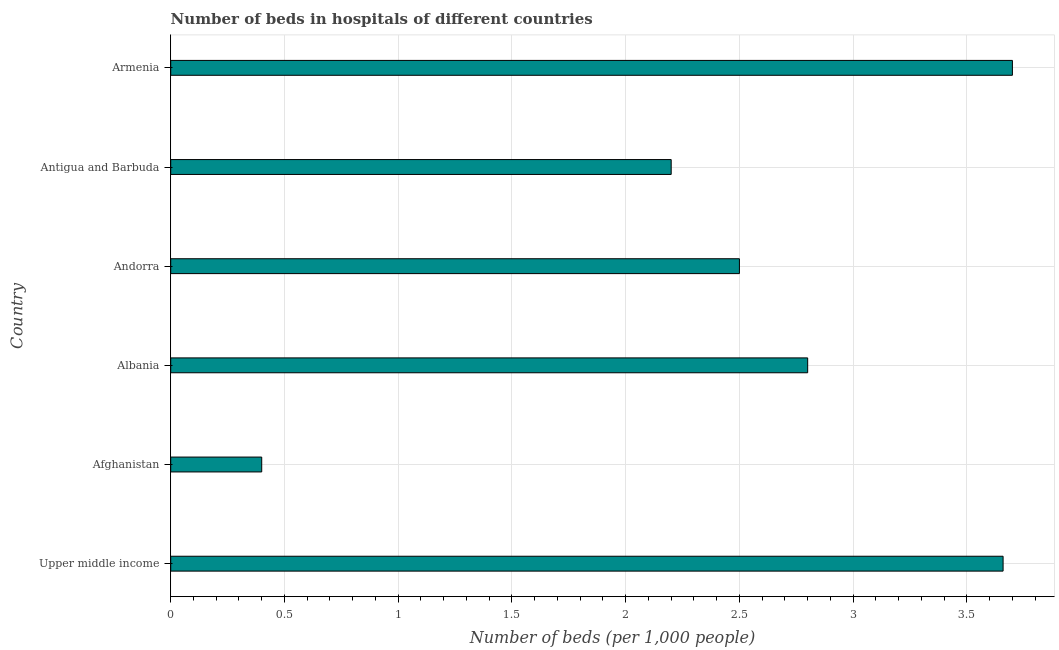Does the graph contain grids?
Provide a succinct answer. Yes. What is the title of the graph?
Offer a terse response. Number of beds in hospitals of different countries. What is the label or title of the X-axis?
Your response must be concise. Number of beds (per 1,0 people). Across all countries, what is the minimum number of hospital beds?
Give a very brief answer. 0.4. In which country was the number of hospital beds maximum?
Your response must be concise. Armenia. In which country was the number of hospital beds minimum?
Offer a very short reply. Afghanistan. What is the sum of the number of hospital beds?
Ensure brevity in your answer.  15.26. What is the average number of hospital beds per country?
Give a very brief answer. 2.54. What is the median number of hospital beds?
Your answer should be compact. 2.65. What is the ratio of the number of hospital beds in Afghanistan to that in Albania?
Provide a succinct answer. 0.14. What is the difference between the highest and the second highest number of hospital beds?
Your response must be concise. 0.04. In how many countries, is the number of hospital beds greater than the average number of hospital beds taken over all countries?
Provide a succinct answer. 3. What is the Number of beds (per 1,000 people) in Upper middle income?
Keep it short and to the point. 3.66. What is the Number of beds (per 1,000 people) in Afghanistan?
Give a very brief answer. 0.4. What is the Number of beds (per 1,000 people) of Andorra?
Provide a short and direct response. 2.5. What is the Number of beds (per 1,000 people) in Antigua and Barbuda?
Provide a succinct answer. 2.2. What is the difference between the Number of beds (per 1,000 people) in Upper middle income and Afghanistan?
Ensure brevity in your answer.  3.26. What is the difference between the Number of beds (per 1,000 people) in Upper middle income and Albania?
Offer a terse response. 0.86. What is the difference between the Number of beds (per 1,000 people) in Upper middle income and Andorra?
Offer a terse response. 1.16. What is the difference between the Number of beds (per 1,000 people) in Upper middle income and Antigua and Barbuda?
Ensure brevity in your answer.  1.46. What is the difference between the Number of beds (per 1,000 people) in Upper middle income and Armenia?
Keep it short and to the point. -0.04. What is the difference between the Number of beds (per 1,000 people) in Afghanistan and Albania?
Your answer should be very brief. -2.4. What is the difference between the Number of beds (per 1,000 people) in Afghanistan and Antigua and Barbuda?
Your answer should be compact. -1.8. What is the difference between the Number of beds (per 1,000 people) in Afghanistan and Armenia?
Your answer should be compact. -3.3. What is the difference between the Number of beds (per 1,000 people) in Albania and Andorra?
Ensure brevity in your answer.  0.3. What is the difference between the Number of beds (per 1,000 people) in Albania and Antigua and Barbuda?
Offer a terse response. 0.6. What is the difference between the Number of beds (per 1,000 people) in Albania and Armenia?
Your answer should be very brief. -0.9. What is the difference between the Number of beds (per 1,000 people) in Andorra and Antigua and Barbuda?
Your response must be concise. 0.3. What is the difference between the Number of beds (per 1,000 people) in Andorra and Armenia?
Your answer should be very brief. -1.2. What is the difference between the Number of beds (per 1,000 people) in Antigua and Barbuda and Armenia?
Ensure brevity in your answer.  -1.5. What is the ratio of the Number of beds (per 1,000 people) in Upper middle income to that in Afghanistan?
Ensure brevity in your answer.  9.15. What is the ratio of the Number of beds (per 1,000 people) in Upper middle income to that in Albania?
Make the answer very short. 1.31. What is the ratio of the Number of beds (per 1,000 people) in Upper middle income to that in Andorra?
Offer a terse response. 1.46. What is the ratio of the Number of beds (per 1,000 people) in Upper middle income to that in Antigua and Barbuda?
Your response must be concise. 1.66. What is the ratio of the Number of beds (per 1,000 people) in Afghanistan to that in Albania?
Make the answer very short. 0.14. What is the ratio of the Number of beds (per 1,000 people) in Afghanistan to that in Andorra?
Provide a short and direct response. 0.16. What is the ratio of the Number of beds (per 1,000 people) in Afghanistan to that in Antigua and Barbuda?
Your response must be concise. 0.18. What is the ratio of the Number of beds (per 1,000 people) in Afghanistan to that in Armenia?
Provide a short and direct response. 0.11. What is the ratio of the Number of beds (per 1,000 people) in Albania to that in Andorra?
Keep it short and to the point. 1.12. What is the ratio of the Number of beds (per 1,000 people) in Albania to that in Antigua and Barbuda?
Your answer should be compact. 1.27. What is the ratio of the Number of beds (per 1,000 people) in Albania to that in Armenia?
Give a very brief answer. 0.76. What is the ratio of the Number of beds (per 1,000 people) in Andorra to that in Antigua and Barbuda?
Give a very brief answer. 1.14. What is the ratio of the Number of beds (per 1,000 people) in Andorra to that in Armenia?
Your answer should be very brief. 0.68. What is the ratio of the Number of beds (per 1,000 people) in Antigua and Barbuda to that in Armenia?
Give a very brief answer. 0.59. 